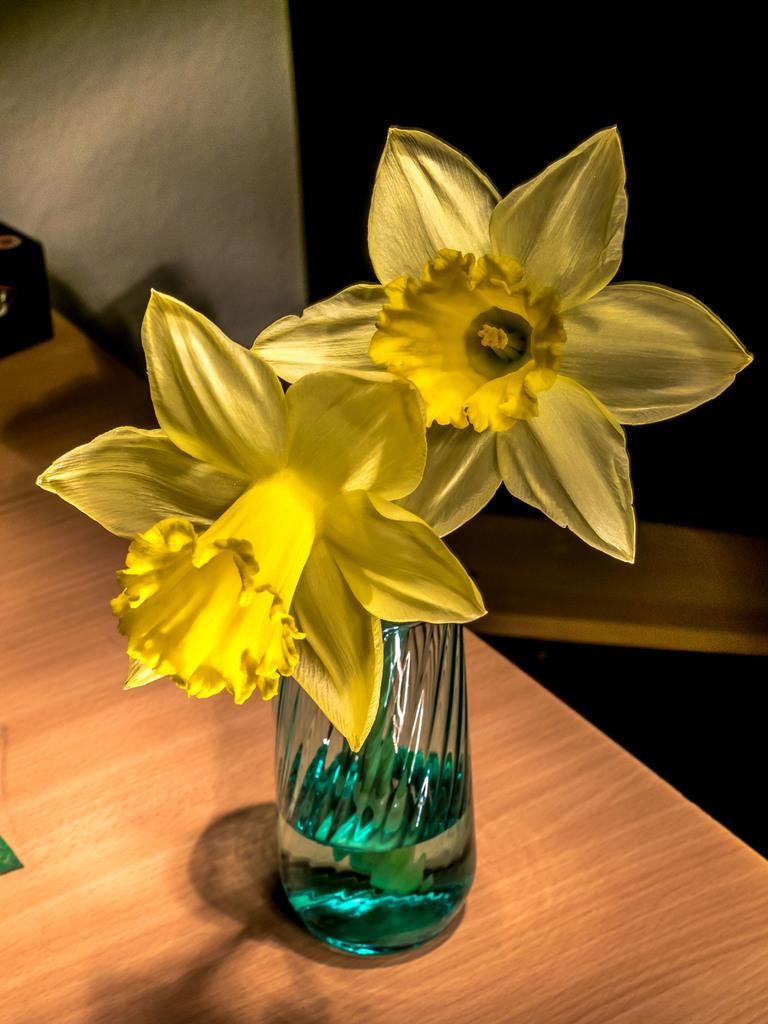What is located in the center of the image? There is a table in the center of the image. What object is placed on the table? There is a glass on the table. What is inside the glass? Flowers are inside the glass. What can be seen in the background of the image? There is a wall in the background of the image. What type of apple is being used as a toy in the image? There is no apple or toy present in the image. What color is the underwear hanging on the wall in the image? There is no underwear present in the image; only a table, glass, flowers, and a wall are visible. 